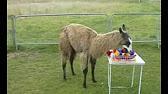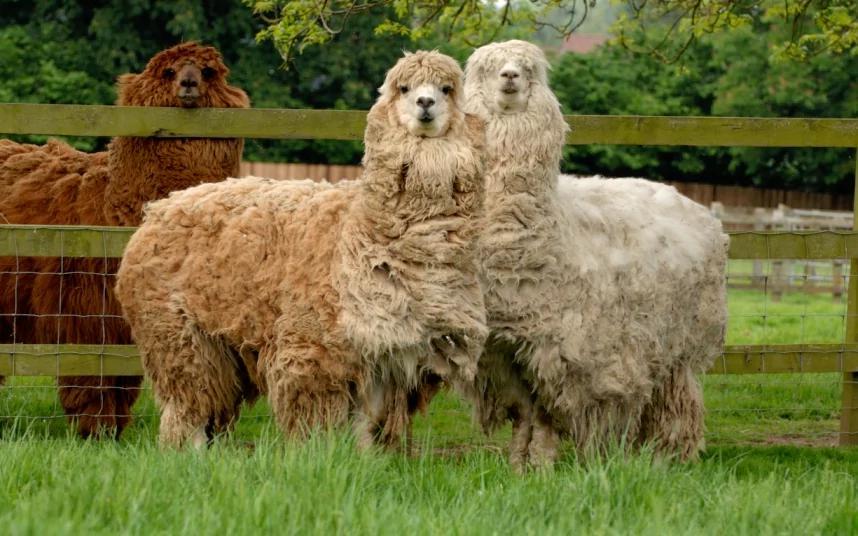The first image is the image on the left, the second image is the image on the right. Analyze the images presented: Is the assertion "There is a human interacting with the livestock." valid? Answer yes or no. No. The first image is the image on the left, the second image is the image on the right. Evaluate the accuracy of this statement regarding the images: "There is one human near at least one llama one oft he images.". Is it true? Answer yes or no. No. 